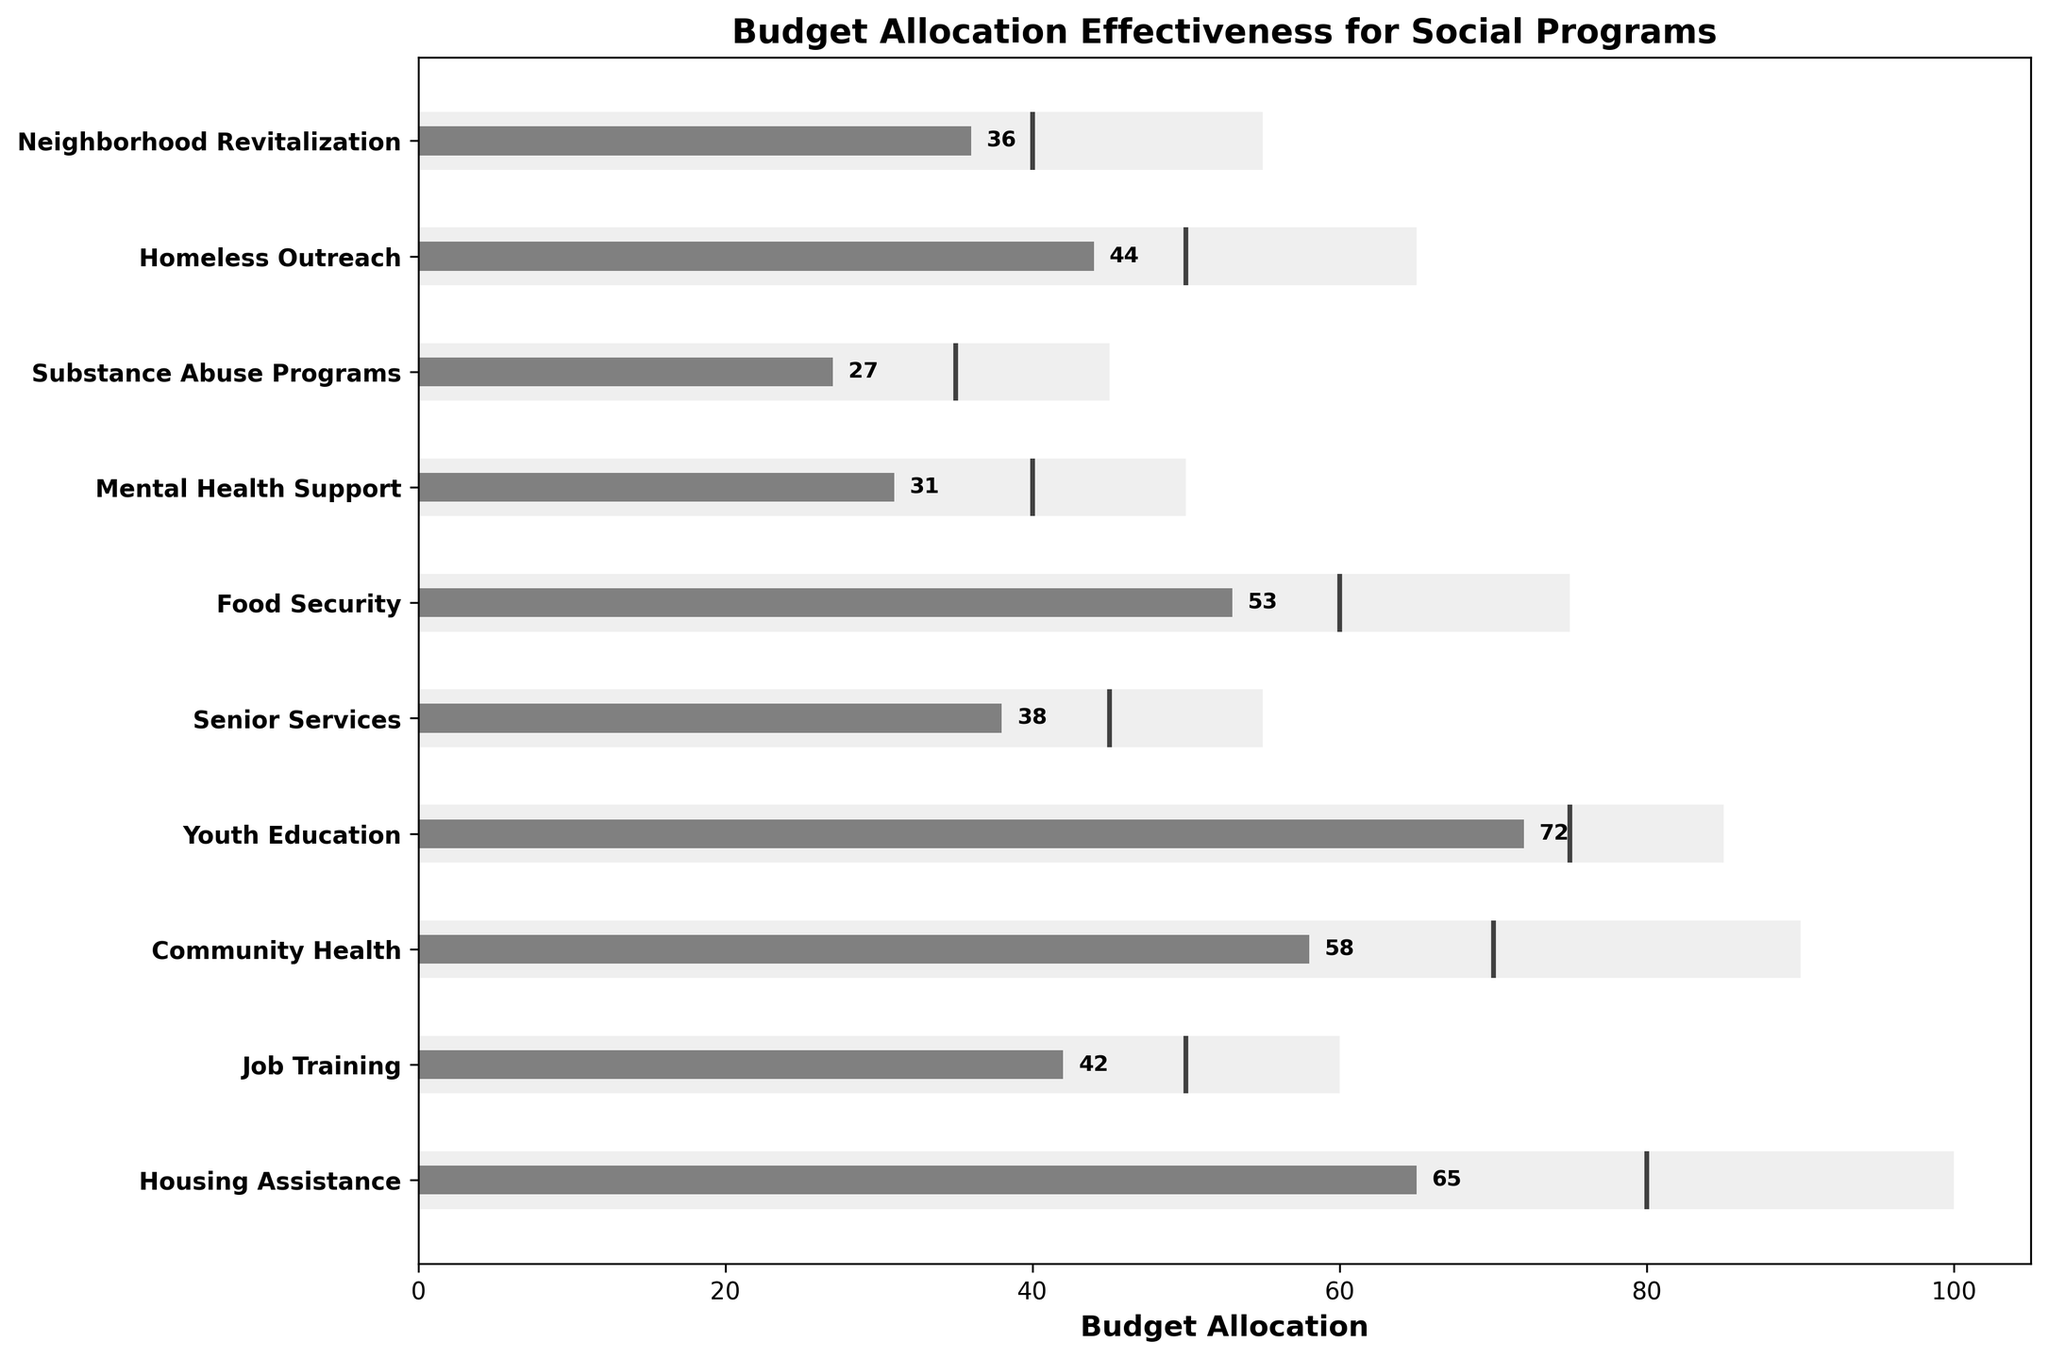What is the title of the chart? The title is usually displayed at the top of the chart. Here, it reads "Budget Allocation Effectiveness for Social Programs".
Answer: Budget Allocation Effectiveness for Social Programs How many social programs are evaluated in the chart? To determine the number of programs, count the number of bars or labeled entries on the y-axis. There are 10 programs listed.
Answer: 10 Which program received the highest actual budget allocation? Look for the bar that extends the furthest to the right among the 'Actual' sections of the bars. "Youth Education" has the highest actual allocation at 72.
Answer: Youth Education How does the actual allocation for "Mental Health Support" compare to its target? Identify the actual value and the target value for "Mental Health Support". The actual is 31, whereas the target is 40. The actual is less than the target.
Answer: Less than the target What is the average actual allocation for all the programs? Sum the actual values for all the programs (65+42+58+72+38+53+31+27+44+36 = 466) and divide by the number of programs (10). The average is 466/10 = 46.6.
Answer: 46.6 What is the difference between the maximum and actual allocations for "Job Training"? The maximum allocation for "Job Training" is 60, and the actual allocation is 42. Subtract the actual from the maximum (60-42) to find the difference.
Answer: 18 Which program is closest to meeting its target allocation? Compare the actual and target values for each program. "Youth Education" with an actual of 72 and a target of 75 is the closest to its target, being 3 units short.
Answer: Youth Education Which program has the largest gap between its actual and target allocations? Calculate the difference between actual and target for each program. "Mental Health Support" has the largest gap with a target of 40 and an actual of 31, resulting in a gap of 9.
Answer: Mental Health Support Which programs exceeded their target allocations? Compare the actual allocations to the targets for each program. There are no programs where the actual allocation exceeds the target.
Answer: None 